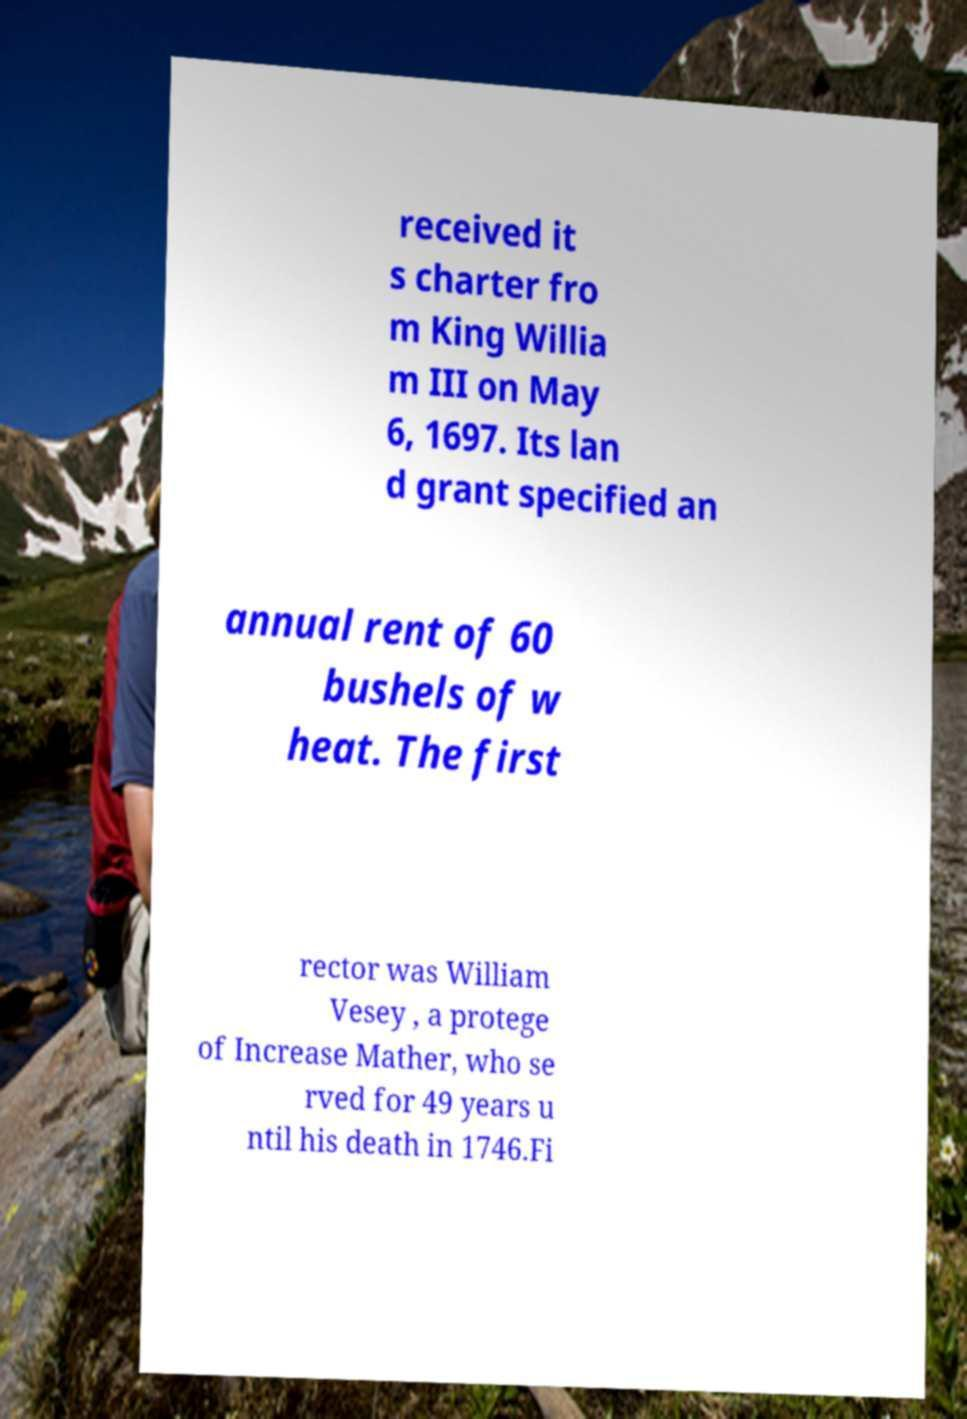I need the written content from this picture converted into text. Can you do that? received it s charter fro m King Willia m III on May 6, 1697. Its lan d grant specified an annual rent of 60 bushels of w heat. The first rector was William Vesey , a protege of Increase Mather, who se rved for 49 years u ntil his death in 1746.Fi 